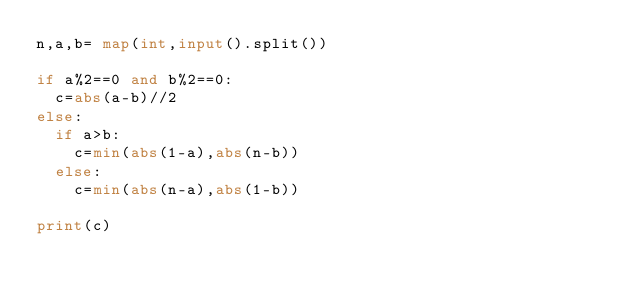Convert code to text. <code><loc_0><loc_0><loc_500><loc_500><_Python_>n,a,b= map(int,input().split())

if a%2==0 and b%2==0:
  c=abs(a-b)//2
else:
  if a>b:
    c=min(abs(1-a),abs(n-b))
  else:
    c=min(abs(n-a),abs(1-b))

print(c)</code> 